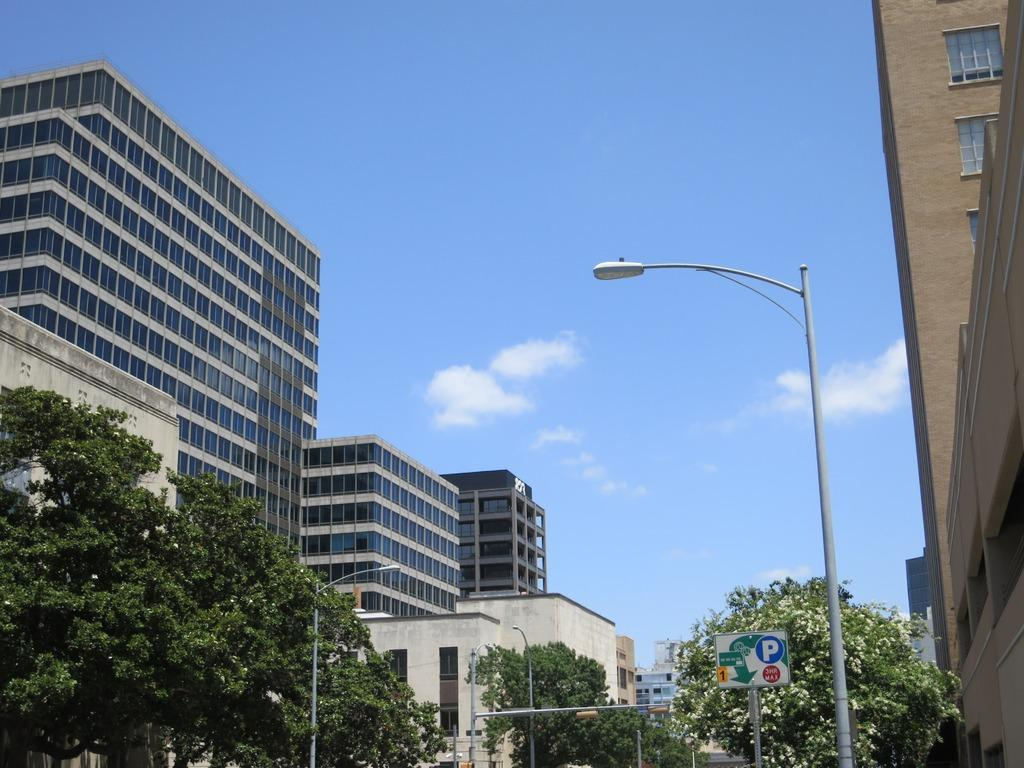What can be found at the bottom of the image? At the bottom of the image, there are poles, trees, and sign boards. What structures are visible behind the objects at the bottom of the image? Buildings can be seen behind the poles, trees, and sign boards. What is visible at the top of the image? At the top of the image, there are clouds and the sky. How many balls are being used in the selection process in the image? There is no selection process or balls present in the image. Can you describe the kiss between the two trees in the image? There are no trees kissing in the image; trees and poles are present, but they are not interacting in any way. 